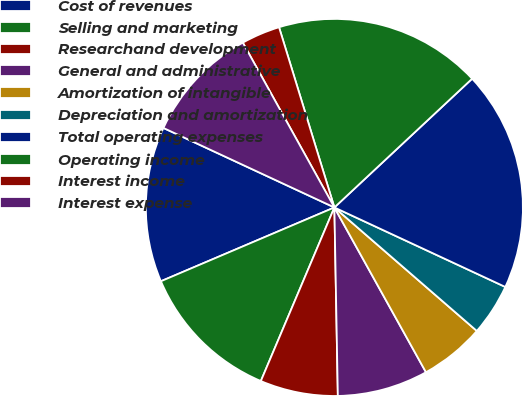Convert chart. <chart><loc_0><loc_0><loc_500><loc_500><pie_chart><fcel>Cost of revenues<fcel>Selling and marketing<fcel>Researchand development<fcel>General and administrative<fcel>Amortization of intangible<fcel>Depreciation and amortization<fcel>Total operating expenses<fcel>Operating income<fcel>Interest income<fcel>Interest expense<nl><fcel>13.33%<fcel>12.22%<fcel>6.67%<fcel>7.78%<fcel>5.56%<fcel>4.44%<fcel>18.89%<fcel>17.78%<fcel>3.33%<fcel>10.0%<nl></chart> 